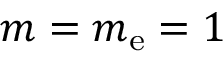<formula> <loc_0><loc_0><loc_500><loc_500>m = m _ { e } = 1</formula> 